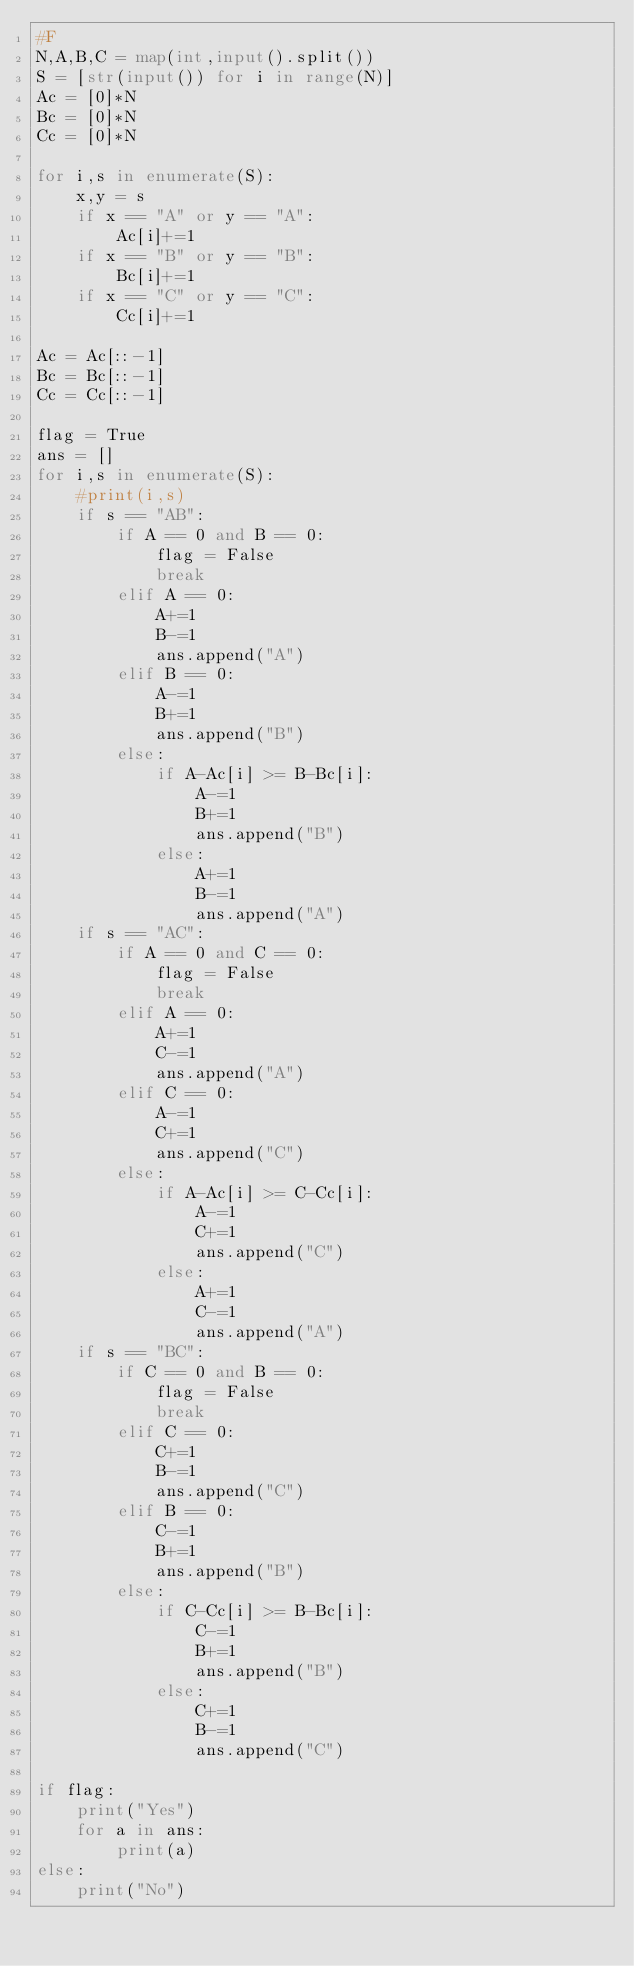Convert code to text. <code><loc_0><loc_0><loc_500><loc_500><_Python_>#F
N,A,B,C = map(int,input().split())
S = [str(input()) for i in range(N)]
Ac = [0]*N
Bc = [0]*N
Cc = [0]*N

for i,s in enumerate(S):
    x,y = s
    if x == "A" or y == "A":
        Ac[i]+=1
    if x == "B" or y == "B":
        Bc[i]+=1
    if x == "C" or y == "C":
        Cc[i]+=1
        
Ac = Ac[::-1]
Bc = Bc[::-1]
Cc = Cc[::-1]
    
flag = True
ans = []
for i,s in enumerate(S):
    #print(i,s)
    if s == "AB":
        if A == 0 and B == 0:
            flag = False
            break
        elif A == 0:
            A+=1
            B-=1
            ans.append("A")
        elif B == 0:
            A-=1
            B+=1
            ans.append("B")
        else:
            if A-Ac[i] >= B-Bc[i]:
                A-=1
                B+=1
                ans.append("B")
            else:
                A+=1
                B-=1
                ans.append("A")
    if s == "AC":
        if A == 0 and C == 0:
            flag = False
            break
        elif A == 0:
            A+=1
            C-=1
            ans.append("A")
        elif C == 0:
            A-=1
            C+=1
            ans.append("C")
        else:
            if A-Ac[i] >= C-Cc[i]:
                A-=1
                C+=1
                ans.append("C")
            else:
                A+=1
                C-=1
                ans.append("A")
    if s == "BC":
        if C == 0 and B == 0:
            flag = False
            break
        elif C == 0:
            C+=1
            B-=1
            ans.append("C")
        elif B == 0:
            C-=1
            B+=1
            ans.append("B")
        else:
            if C-Cc[i] >= B-Bc[i]:
                C-=1
                B+=1
                ans.append("B")
            else:
                C+=1
                B-=1
                ans.append("C")
                
if flag:
    print("Yes")
    for a in ans:
        print(a)
else:
    print("No")
    
    

</code> 